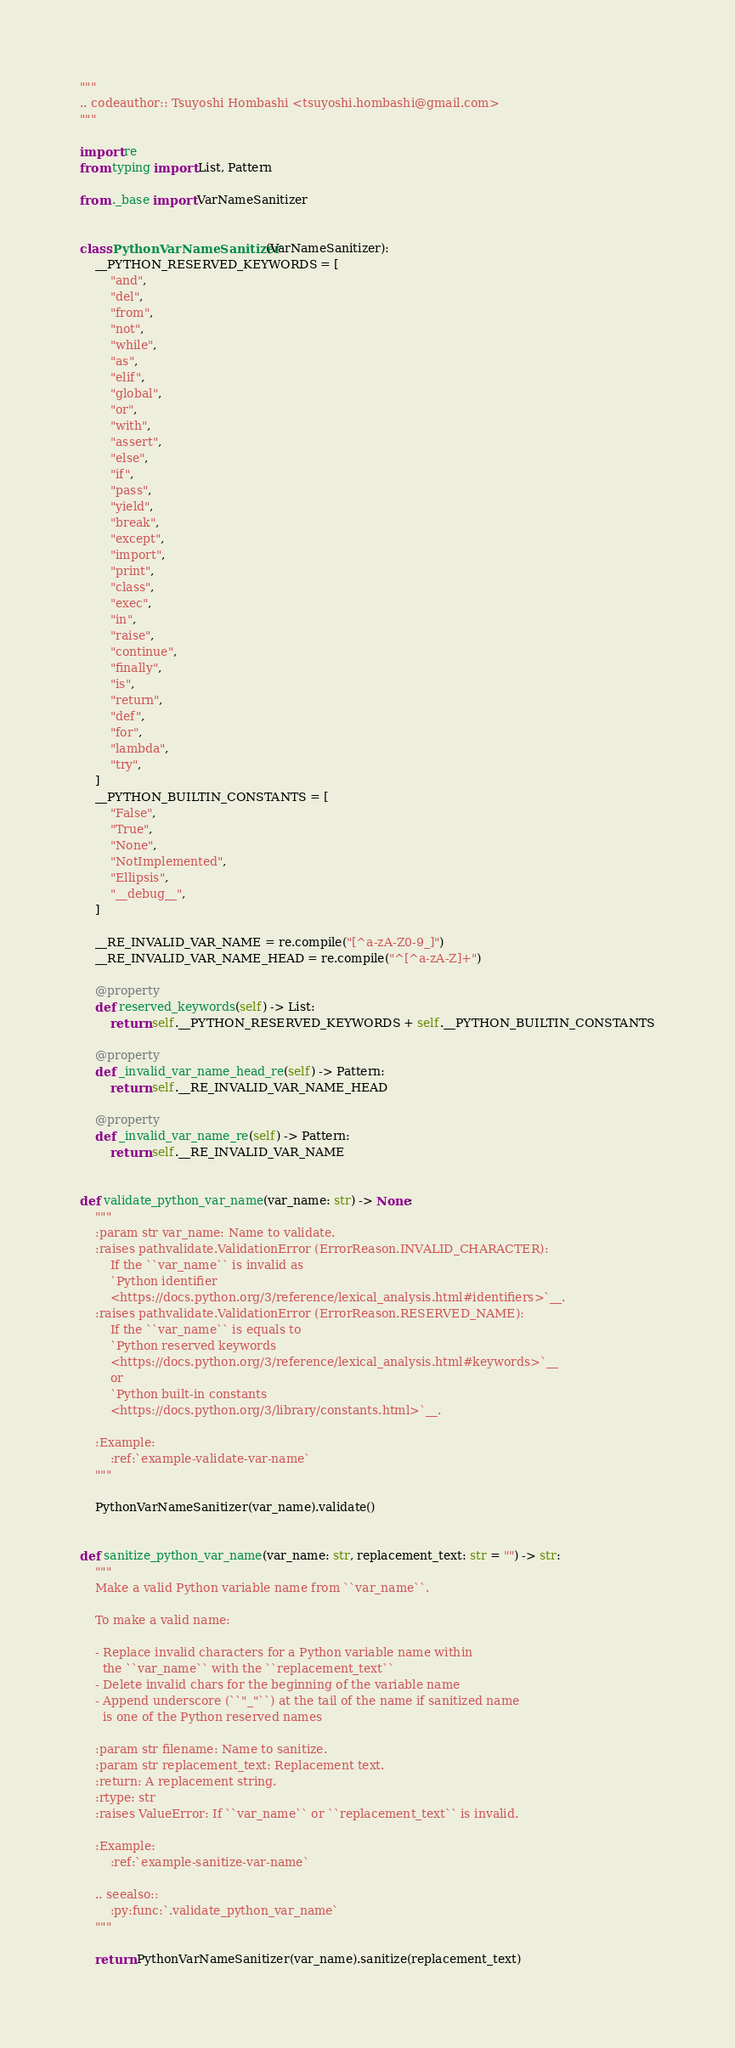<code> <loc_0><loc_0><loc_500><loc_500><_Python_>"""
.. codeauthor:: Tsuyoshi Hombashi <tsuyoshi.hombashi@gmail.com>
"""

import re
from typing import List, Pattern

from ._base import VarNameSanitizer


class PythonVarNameSanitizer(VarNameSanitizer):
    __PYTHON_RESERVED_KEYWORDS = [
        "and",
        "del",
        "from",
        "not",
        "while",
        "as",
        "elif",
        "global",
        "or",
        "with",
        "assert",
        "else",
        "if",
        "pass",
        "yield",
        "break",
        "except",
        "import",
        "print",
        "class",
        "exec",
        "in",
        "raise",
        "continue",
        "finally",
        "is",
        "return",
        "def",
        "for",
        "lambda",
        "try",
    ]
    __PYTHON_BUILTIN_CONSTANTS = [
        "False",
        "True",
        "None",
        "NotImplemented",
        "Ellipsis",
        "__debug__",
    ]

    __RE_INVALID_VAR_NAME = re.compile("[^a-zA-Z0-9_]")
    __RE_INVALID_VAR_NAME_HEAD = re.compile("^[^a-zA-Z]+")

    @property
    def reserved_keywords(self) -> List:
        return self.__PYTHON_RESERVED_KEYWORDS + self.__PYTHON_BUILTIN_CONSTANTS

    @property
    def _invalid_var_name_head_re(self) -> Pattern:
        return self.__RE_INVALID_VAR_NAME_HEAD

    @property
    def _invalid_var_name_re(self) -> Pattern:
        return self.__RE_INVALID_VAR_NAME


def validate_python_var_name(var_name: str) -> None:
    """
    :param str var_name: Name to validate.
    :raises pathvalidate.ValidationError (ErrorReason.INVALID_CHARACTER):
        If the ``var_name`` is invalid as
        `Python identifier
        <https://docs.python.org/3/reference/lexical_analysis.html#identifiers>`__.
    :raises pathvalidate.ValidationError (ErrorReason.RESERVED_NAME):
        If the ``var_name`` is equals to
        `Python reserved keywords
        <https://docs.python.org/3/reference/lexical_analysis.html#keywords>`__
        or
        `Python built-in constants
        <https://docs.python.org/3/library/constants.html>`__.

    :Example:
        :ref:`example-validate-var-name`
    """

    PythonVarNameSanitizer(var_name).validate()


def sanitize_python_var_name(var_name: str, replacement_text: str = "") -> str:
    """
    Make a valid Python variable name from ``var_name``.

    To make a valid name:

    - Replace invalid characters for a Python variable name within
      the ``var_name`` with the ``replacement_text``
    - Delete invalid chars for the beginning of the variable name
    - Append underscore (``"_"``) at the tail of the name if sanitized name
      is one of the Python reserved names

    :param str filename: Name to sanitize.
    :param str replacement_text: Replacement text.
    :return: A replacement string.
    :rtype: str
    :raises ValueError: If ``var_name`` or ``replacement_text`` is invalid.

    :Example:
        :ref:`example-sanitize-var-name`

    .. seealso::
        :py:func:`.validate_python_var_name`
    """

    return PythonVarNameSanitizer(var_name).sanitize(replacement_text)
</code> 